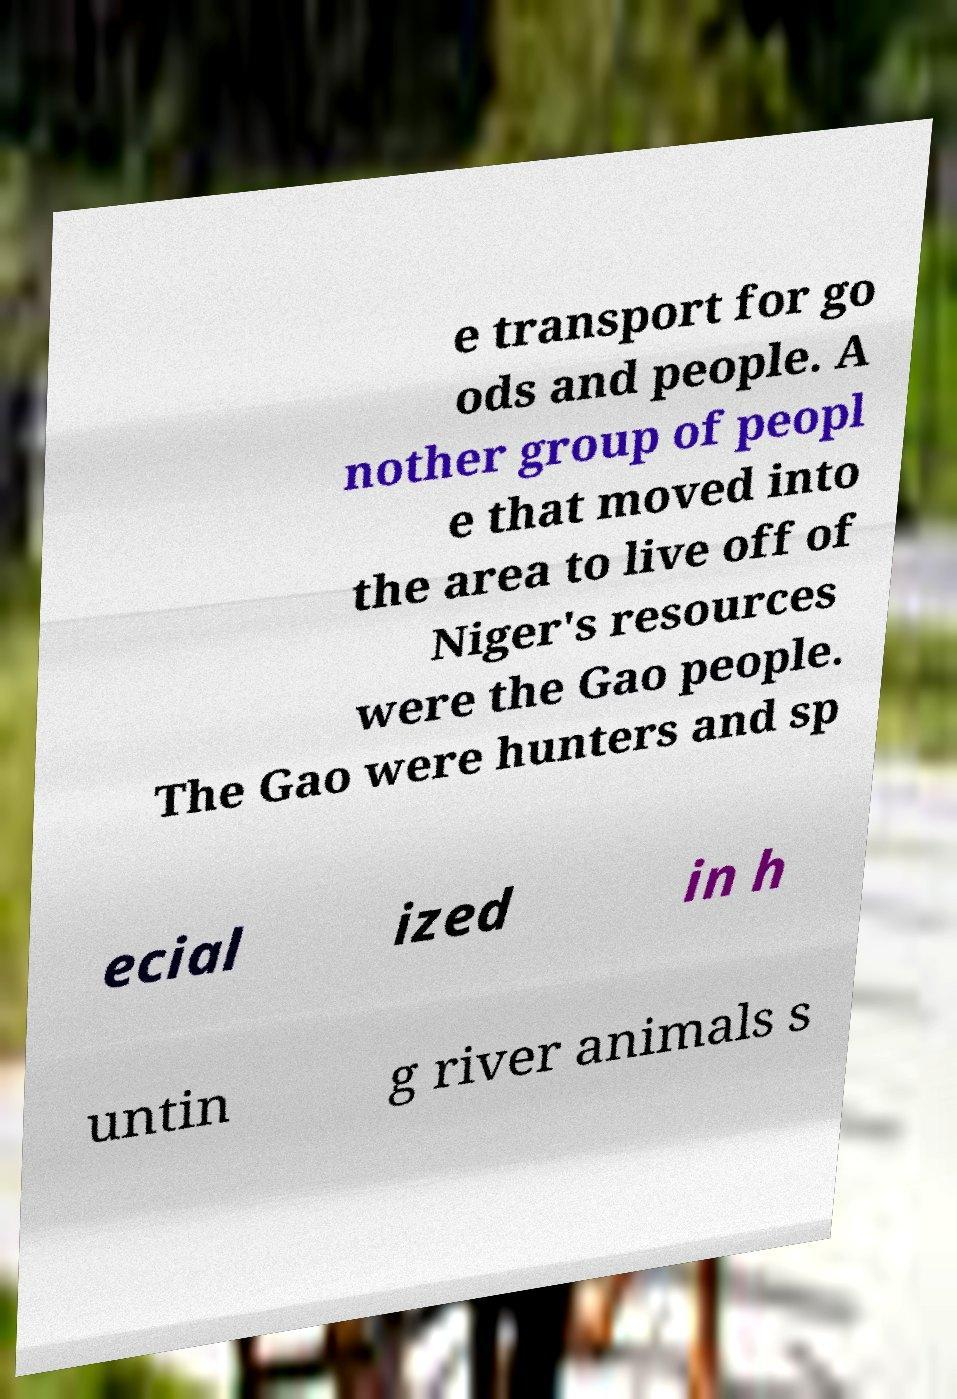Can you read and provide the text displayed in the image?This photo seems to have some interesting text. Can you extract and type it out for me? e transport for go ods and people. A nother group of peopl e that moved into the area to live off of Niger's resources were the Gao people. The Gao were hunters and sp ecial ized in h untin g river animals s 